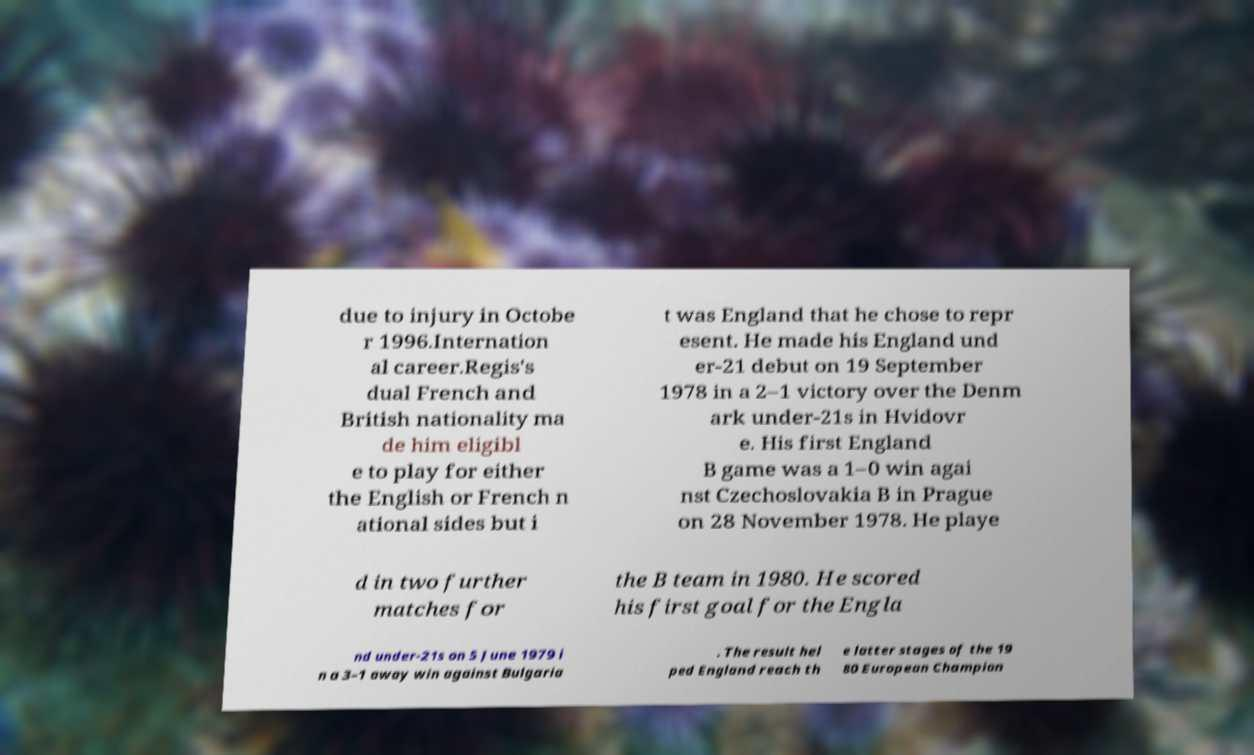For documentation purposes, I need the text within this image transcribed. Could you provide that? due to injury in Octobe r 1996.Internation al career.Regis's dual French and British nationality ma de him eligibl e to play for either the English or French n ational sides but i t was England that he chose to repr esent. He made his England und er-21 debut on 19 September 1978 in a 2–1 victory over the Denm ark under-21s in Hvidovr e. His first England B game was a 1–0 win agai nst Czechoslovakia B in Prague on 28 November 1978. He playe d in two further matches for the B team in 1980. He scored his first goal for the Engla nd under-21s on 5 June 1979 i n a 3–1 away win against Bulgaria . The result hel ped England reach th e latter stages of the 19 80 European Champion 